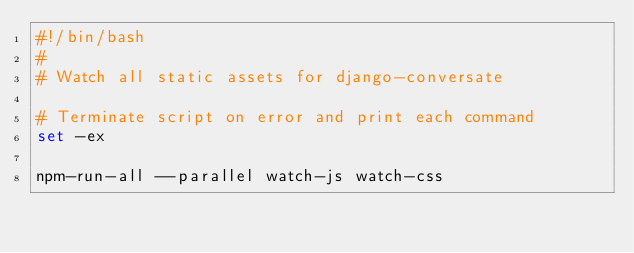<code> <loc_0><loc_0><loc_500><loc_500><_Bash_>#!/bin/bash
#
# Watch all static assets for django-conversate

# Terminate script on error and print each command
set -ex

npm-run-all --parallel watch-js watch-css
</code> 